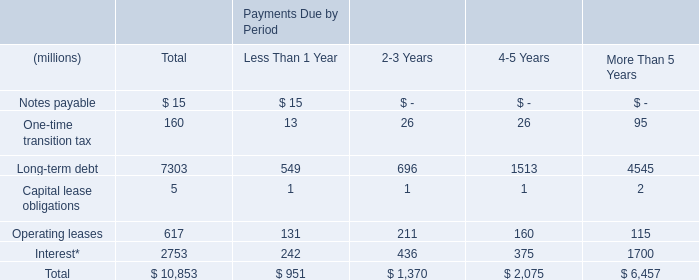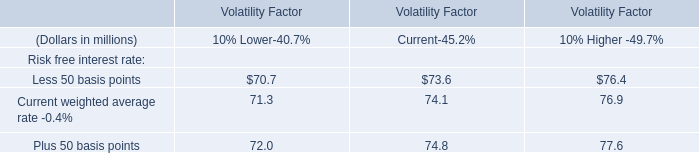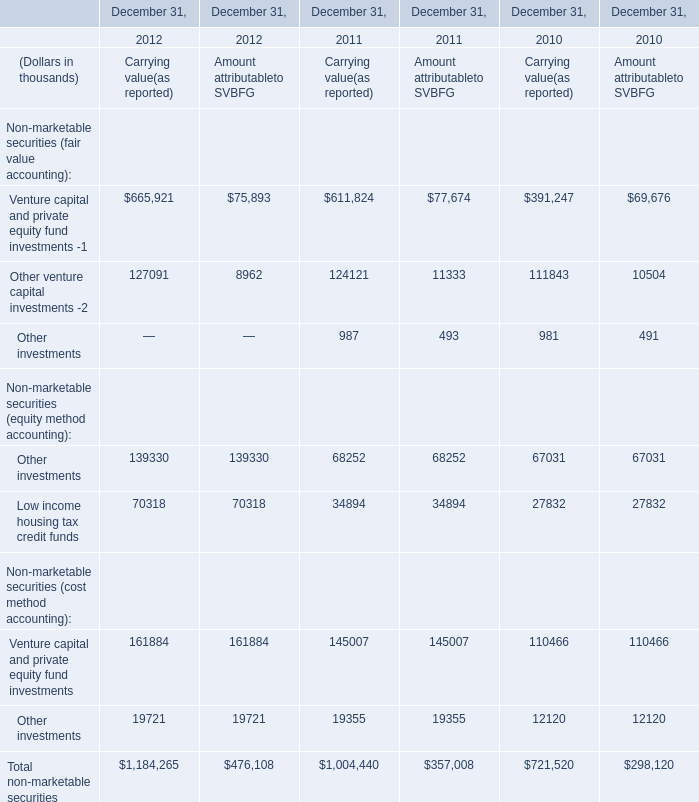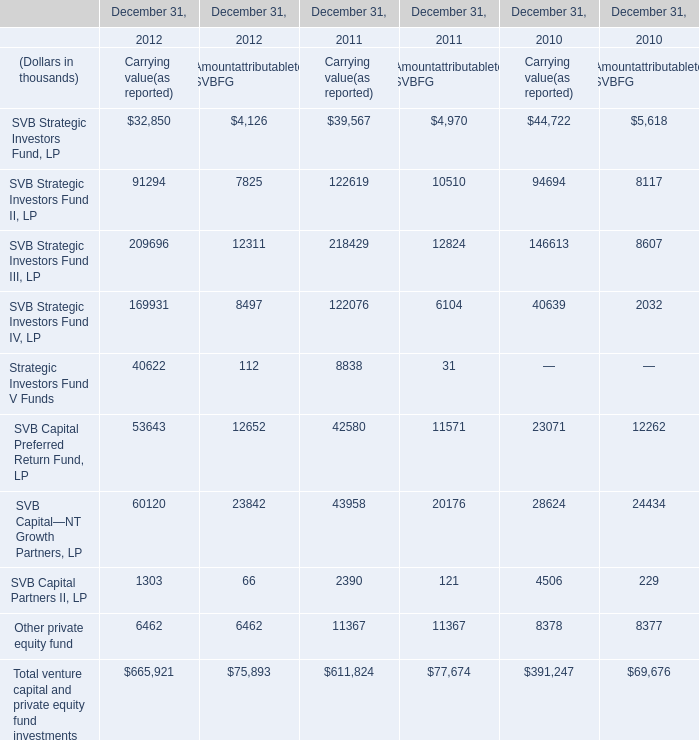What is the sum of the SVB Strategic Investors Fund II, LP in the sections where SVB Strategic Investors Fund, LP is positive? (in thousand) 
Computations: (((((91294 + 7825) + 122619) + 10510) + 94694) + 8117)
Answer: 335059.0. 